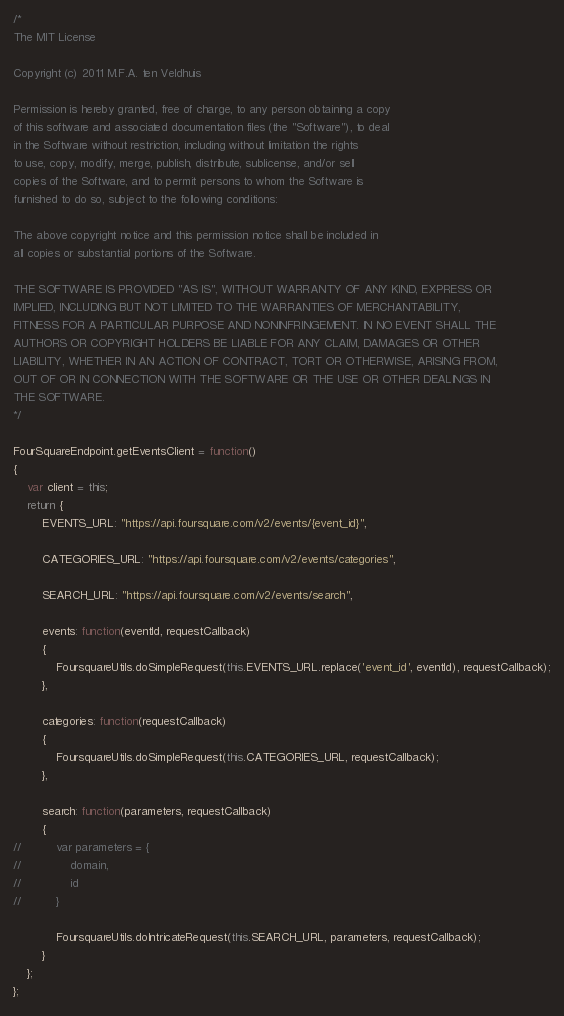Convert code to text. <code><loc_0><loc_0><loc_500><loc_500><_JavaScript_>/*
The MIT License

Copyright (c) 2011 M.F.A. ten Veldhuis

Permission is hereby granted, free of charge, to any person obtaining a copy
of this software and associated documentation files (the "Software"), to deal
in the Software without restriction, including without limitation the rights
to use, copy, modify, merge, publish, distribute, sublicense, and/or sell
copies of the Software, and to permit persons to whom the Software is
furnished to do so, subject to the following conditions:

The above copyright notice and this permission notice shall be included in
all copies or substantial portions of the Software.

THE SOFTWARE IS PROVIDED "AS IS", WITHOUT WARRANTY OF ANY KIND, EXPRESS OR
IMPLIED, INCLUDING BUT NOT LIMITED TO THE WARRANTIES OF MERCHANTABILITY,
FITNESS FOR A PARTICULAR PURPOSE AND NONINFRINGEMENT. IN NO EVENT SHALL THE
AUTHORS OR COPYRIGHT HOLDERS BE LIABLE FOR ANY CLAIM, DAMAGES OR OTHER
LIABILITY, WHETHER IN AN ACTION OF CONTRACT, TORT OR OTHERWISE, ARISING FROM,
OUT OF OR IN CONNECTION WITH THE SOFTWARE OR THE USE OR OTHER DEALINGS IN
THE SOFTWARE.
*/

FourSquareEndpoint.getEventsClient = function()
{
	var client = this;
	return {
		EVENTS_URL: "https://api.foursquare.com/v2/events/{event_id}",
		
		CATEGORIES_URL: "https://api.foursquare.com/v2/events/categories",
		
		SEARCH_URL: "https://api.foursquare.com/v2/events/search",
		
		events: function(eventId, requestCallback)
		{
			FoursquareUtils.doSimpleRequest(this.EVENTS_URL.replace('event_id', eventId), requestCallback);
		},
		
		categories: function(requestCallback)
		{
			FoursquareUtils.doSimpleRequest(this.CATEGORIES_URL, requestCallback);
		},
		
		search: function(parameters, requestCallback)
		{
//			var parameters = {
//				domain,
//				id
//			}
			
			FoursquareUtils.doIntricateRequest(this.SEARCH_URL, parameters, requestCallback);
		}
	};
};</code> 